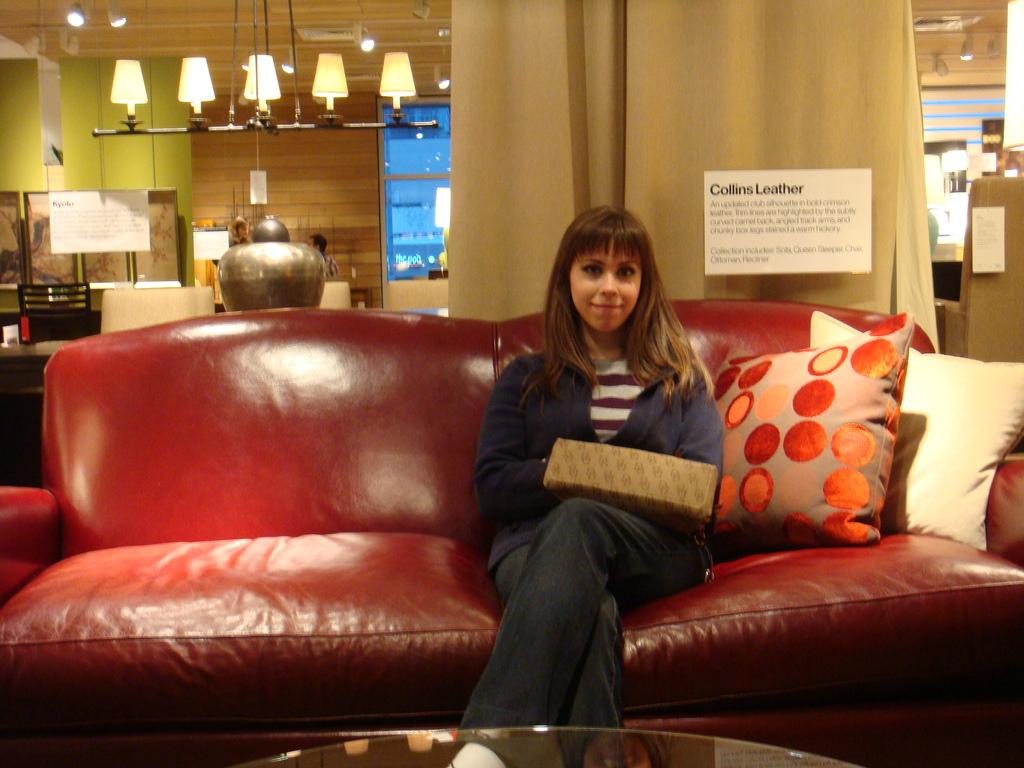What is the woman sitting on in the image? The woman is sitting on a red couch. What can be found on the red couch? The red couch has pillows. What is present in the background of the image? There is a curtain and lights visible far away. What is on the wall in the image? There is a poster on a wall. What other furniture is in the image? There is a chair in the image. What is the woman holding in the image? The woman is holding a handbag. Where is the faucet located in the image? There is no faucet present in the image. What type of bird is perched on the wren in the image? There is no wren or bird present in the image. 